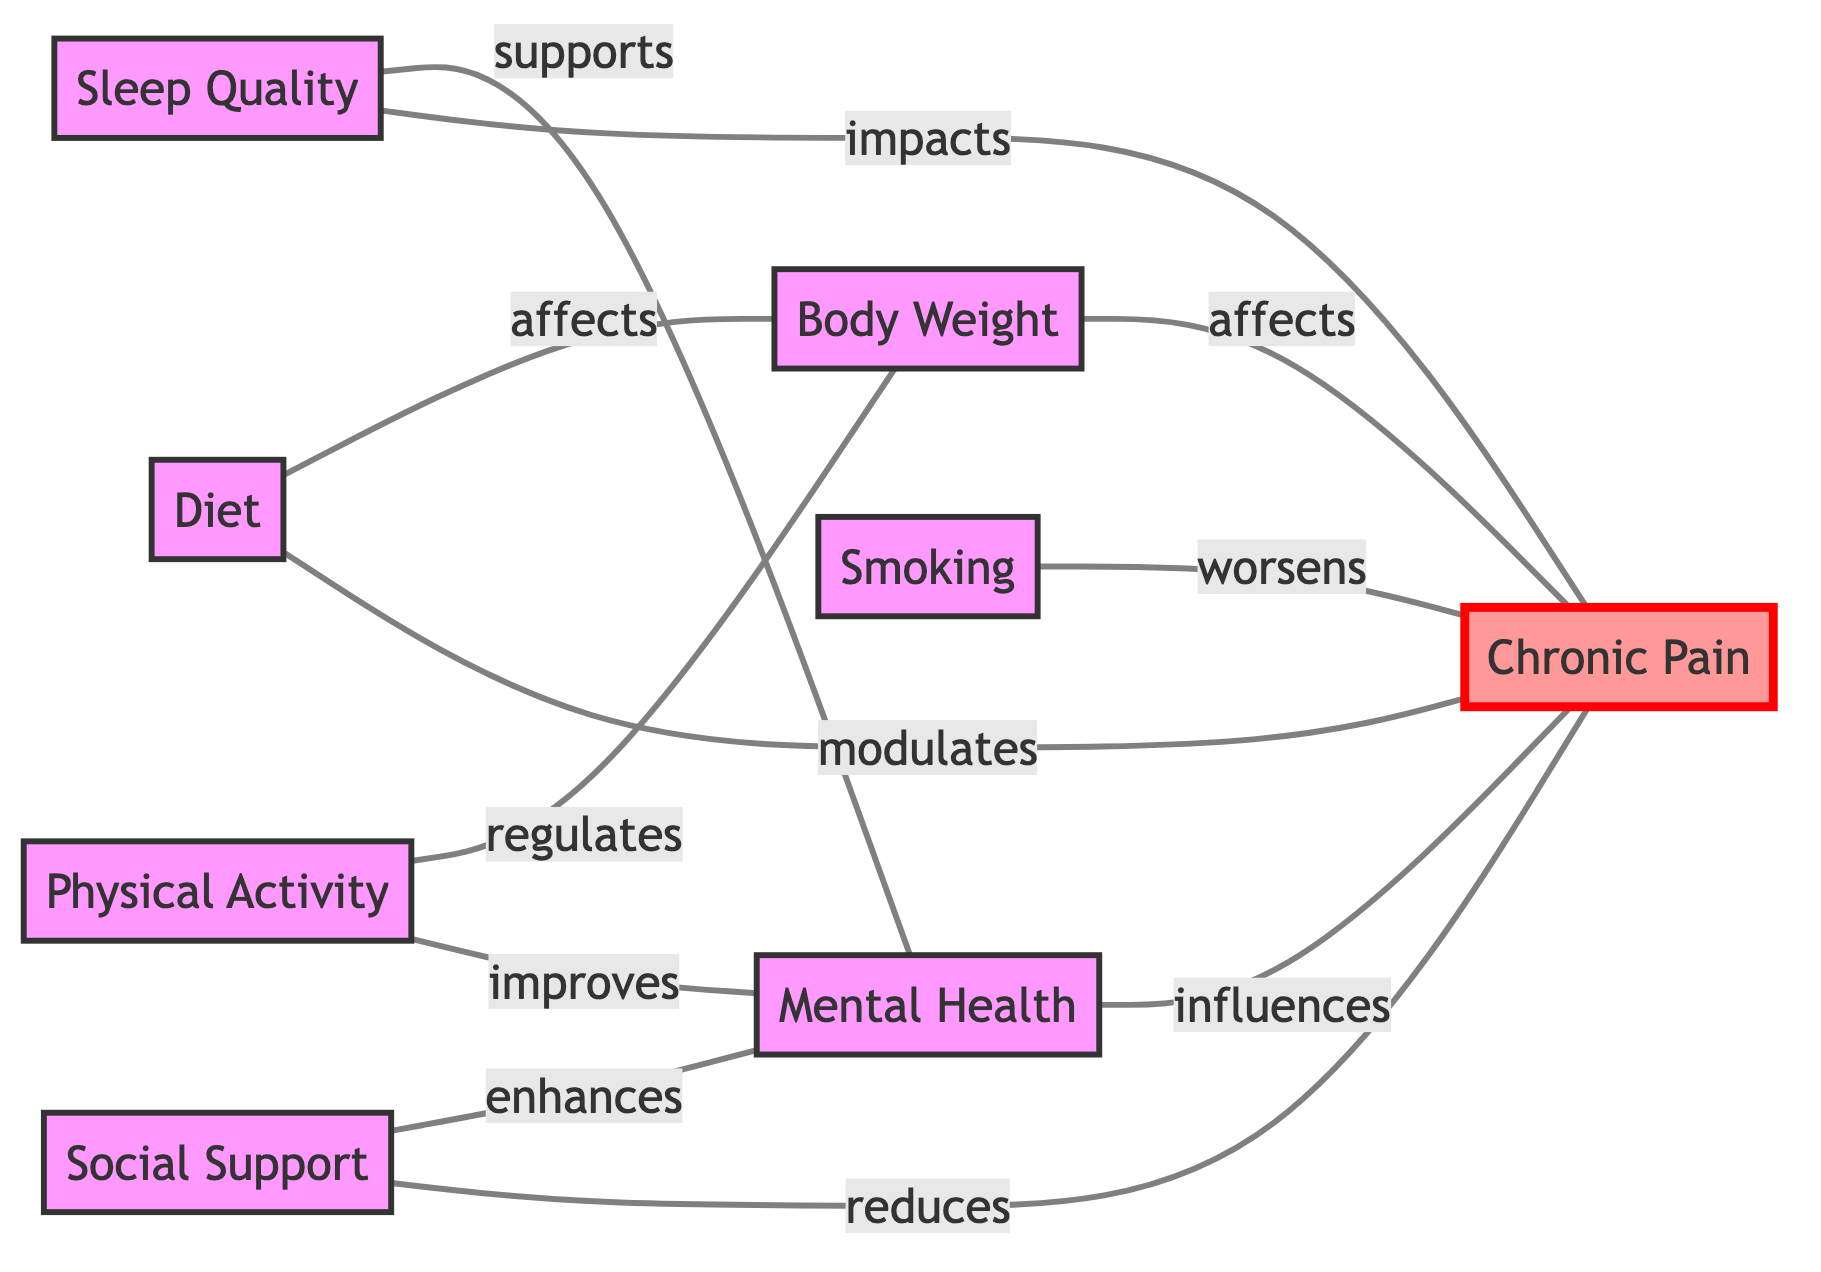What is the total number of nodes in the diagram? The diagram has 8 nodes, which are: Diet, Physical Activity, Sleep Quality, Mental Health, Chronic Pain, Body Weight, Smoking, and Social Support.
Answer: 8 What relationship do Smoking and Chronic Pain have? The diagram shows that Smoking worsens Chronic Pain, indicated by the labeled edge between the two nodes.
Answer: worsens Which factor directly influences Mental Health? Physical Activity directly improves Mental Health, as shown by the edge connecting the two nodes with the "improves" label.
Answer: Physical Activity How many edges are present in the diagram? By counting the connections shown in the graph, there are 10 edges indicating relationships between the nodes.
Answer: 10 What does Diet modulate in the context of this diagram? The edge between Diet and Chronic Pain indicates that Diet modulates Chronic Pain, as labeled in the diagram.
Answer: Chronic Pain Which lifestyle factor enhances Mental Health? Social Support enhances Mental Health, as indicated by the labeled edge that connects the two nodes.
Answer: Social Support How does Sleep Quality relate to Chronic Pain? There are two relationships: Sleep Quality impacts Chronic Pain, and it supports Mental Health, which also influences Chronic Pain, demonstrating a multi-faceted connection.
Answer: impacts What is the direct effect of Body Weight on Chronic Pain? Body Weight affects Chronic Pain, as indicated by the labeled edge connecting these two nodes in the diagram.
Answer: affects Which nodes are connected to Chronic Pain? Chronic Pain is connected to Diet, Sleep Quality, Mental Health, Body Weight, Smoking, and Social Support, totaling six nodes that have direct relationships.
Answer: 6 nodes What regulates Body Weight according to the diagram? Physical Activity regulates Body Weight, as the edge between these two nodes indicates this regulatory relationship.
Answer: Physical Activity 